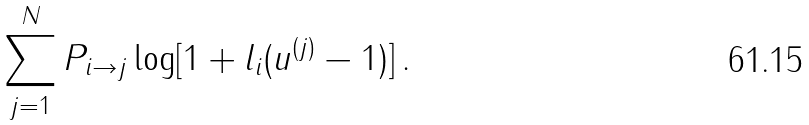<formula> <loc_0><loc_0><loc_500><loc_500>\sum _ { j = 1 } ^ { N } P _ { i \to j } \log [ 1 + l _ { i } ( u ^ { ( j ) } - 1 ) ] \, .</formula> 